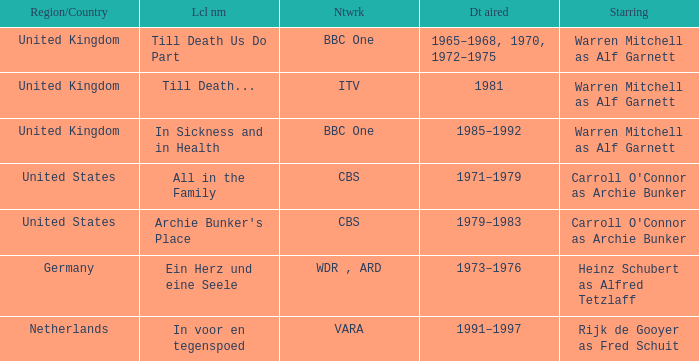What is the name of the network in the United Kingdom which aired in 1985–1992? BBC One. 